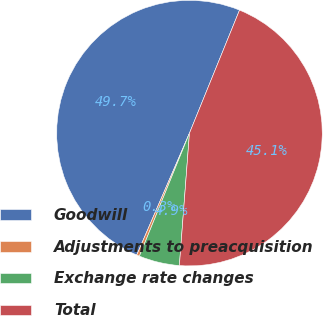Convert chart to OTSL. <chart><loc_0><loc_0><loc_500><loc_500><pie_chart><fcel>Goodwill<fcel>Adjustments to preacquisition<fcel>Exchange rate changes<fcel>Total<nl><fcel>49.65%<fcel>0.35%<fcel>4.94%<fcel>45.06%<nl></chart> 